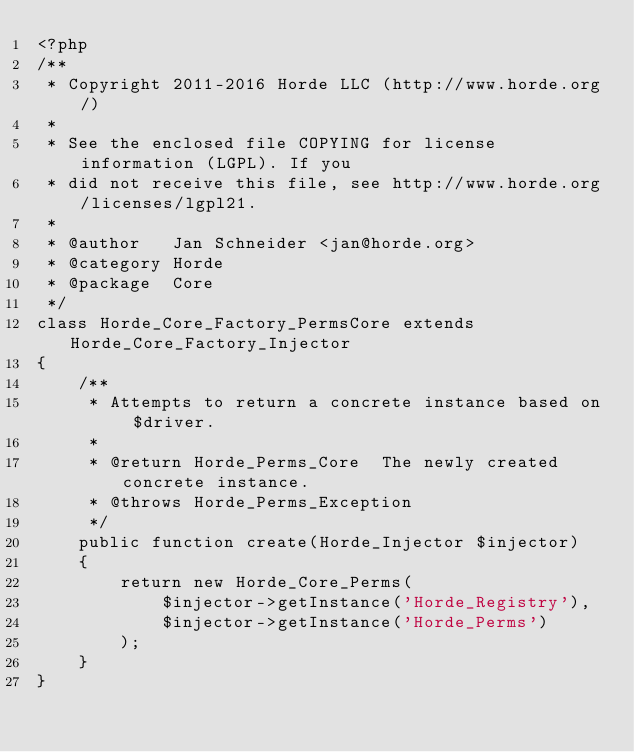<code> <loc_0><loc_0><loc_500><loc_500><_PHP_><?php
/**
 * Copyright 2011-2016 Horde LLC (http://www.horde.org/)
 *
 * See the enclosed file COPYING for license information (LGPL). If you
 * did not receive this file, see http://www.horde.org/licenses/lgpl21.
 *
 * @author   Jan Schneider <jan@horde.org>
 * @category Horde
 * @package  Core
 */
class Horde_Core_Factory_PermsCore extends Horde_Core_Factory_Injector
{
    /**
     * Attempts to return a concrete instance based on $driver.
     *
     * @return Horde_Perms_Core  The newly created concrete instance.
     * @throws Horde_Perms_Exception
     */
    public function create(Horde_Injector $injector)
    {
        return new Horde_Core_Perms(
            $injector->getInstance('Horde_Registry'),
            $injector->getInstance('Horde_Perms')
        );
    }
}
</code> 